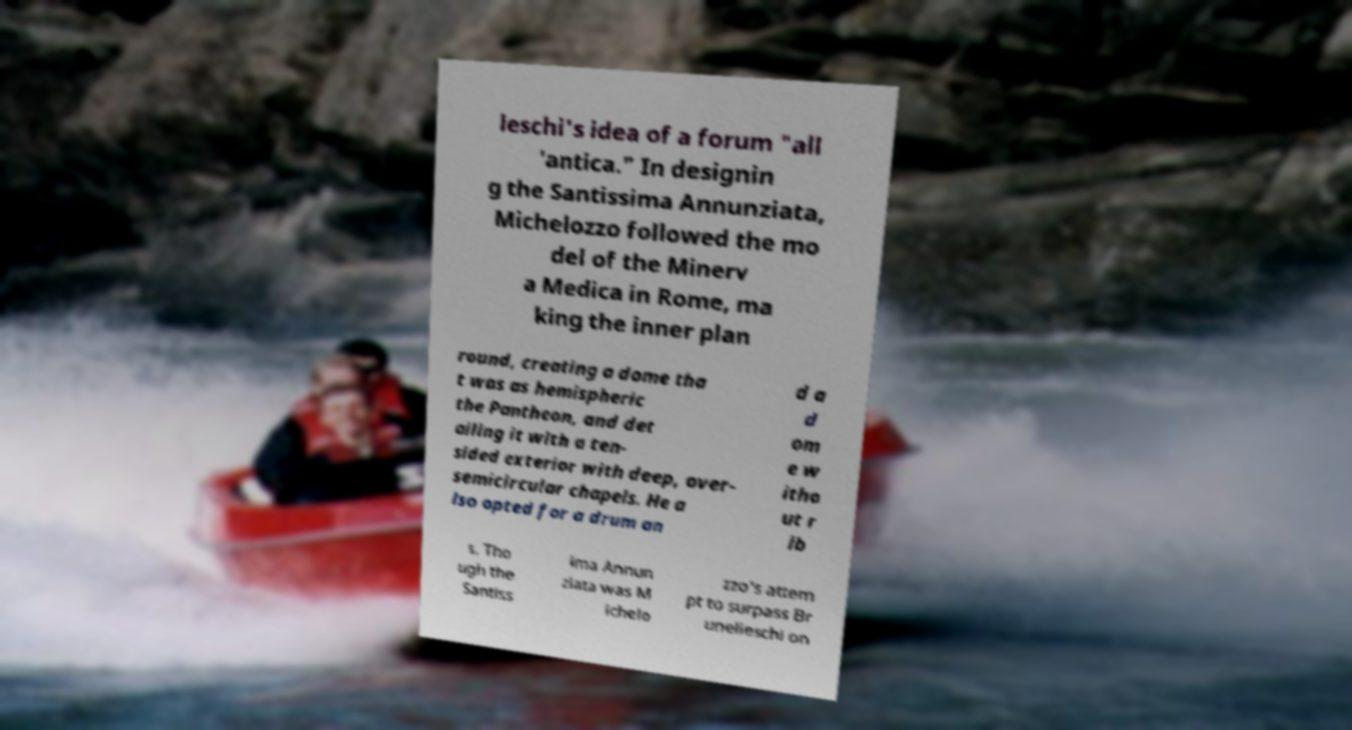Can you read and provide the text displayed in the image?This photo seems to have some interesting text. Can you extract and type it out for me? leschi's idea of a forum "all 'antica." In designin g the Santissima Annunziata, Michelozzo followed the mo del of the Minerv a Medica in Rome, ma king the inner plan round, creating a dome tha t was as hemispheric the Pantheon, and det ailing it with a ten- sided exterior with deep, over- semicircular chapels. He a lso opted for a drum an d a d om e w itho ut r ib s. Tho ugh the Santiss ima Annun ziata was M ichelo zzo's attem pt to surpass Br unelleschi on 